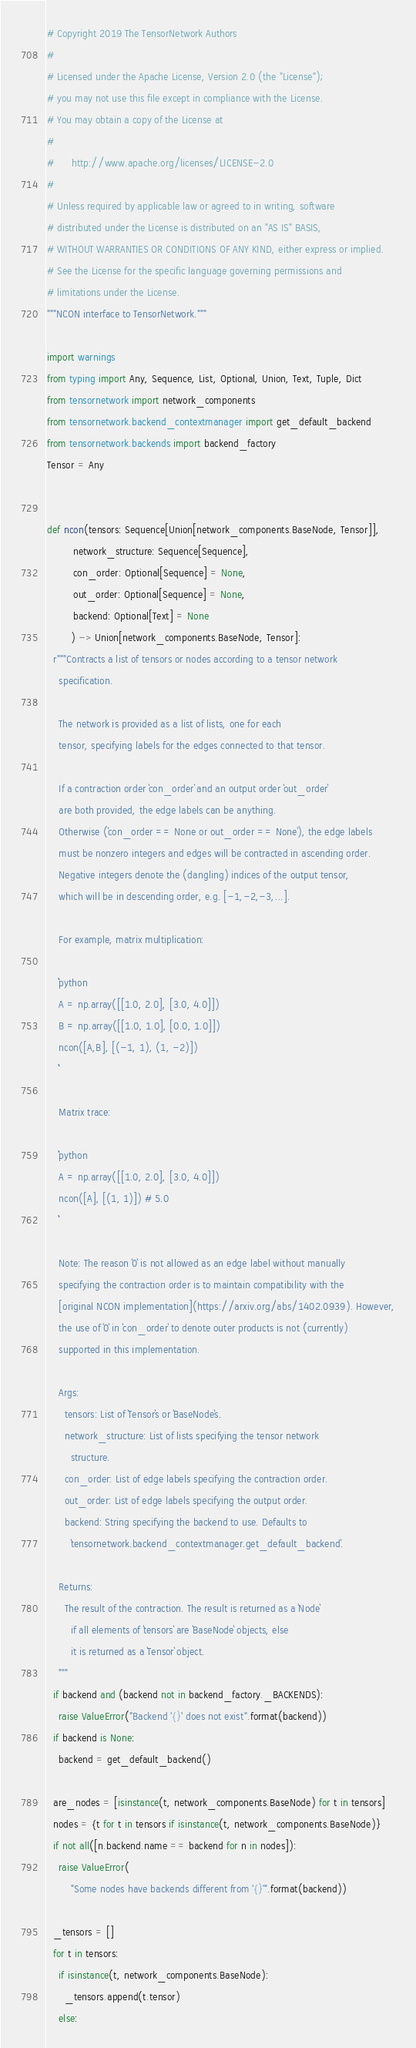Convert code to text. <code><loc_0><loc_0><loc_500><loc_500><_Python_># Copyright 2019 The TensorNetwork Authors
#
# Licensed under the Apache License, Version 2.0 (the "License");
# you may not use this file except in compliance with the License.
# You may obtain a copy of the License at
#
#      http://www.apache.org/licenses/LICENSE-2.0
#
# Unless required by applicable law or agreed to in writing, software
# distributed under the License is distributed on an "AS IS" BASIS,
# WITHOUT WARRANTIES OR CONDITIONS OF ANY KIND, either express or implied.
# See the License for the specific language governing permissions and
# limitations under the License.
"""NCON interface to TensorNetwork."""

import warnings
from typing import Any, Sequence, List, Optional, Union, Text, Tuple, Dict
from tensornetwork import network_components
from tensornetwork.backend_contextmanager import get_default_backend
from tensornetwork.backends import backend_factory
Tensor = Any


def ncon(tensors: Sequence[Union[network_components.BaseNode, Tensor]],
         network_structure: Sequence[Sequence],
         con_order: Optional[Sequence] = None,
         out_order: Optional[Sequence] = None,
         backend: Optional[Text] = None
        ) -> Union[network_components.BaseNode, Tensor]:
  r"""Contracts a list of tensors or nodes according to a tensor network 
    specification.

    The network is provided as a list of lists, one for each
    tensor, specifying labels for the edges connected to that tensor.

    If a contraction order `con_order` and an output order `out_order`
    are both provided, the edge labels can be anything.
    Otherwise (`con_order == None or out_order == None`), the edge labels 
    must be nonzero integers and edges will be contracted in ascending order.
    Negative integers denote the (dangling) indices of the output tensor,
    which will be in descending order, e.g. [-1,-2,-3,...].

    For example, matrix multiplication:

    ```python
    A = np.array([[1.0, 2.0], [3.0, 4.0]])
    B = np.array([[1.0, 1.0], [0.0, 1.0]])
    ncon([A,B], [(-1, 1), (1, -2)])
    ```

    Matrix trace:

    ```python
    A = np.array([[1.0, 2.0], [3.0, 4.0]])
    ncon([A], [(1, 1)]) # 5.0
    ```

    Note: The reason `0` is not allowed as an edge label without manually
    specifying the contraction order is to maintain compatibility with the
    [original NCON implementation](https://arxiv.org/abs/1402.0939). However,
    the use of `0` in `con_order` to denote outer products is not (currently) 
    supported in this implementation.

    Args:
      tensors: List of `Tensor`s or `BaseNode`s.
      network_structure: List of lists specifying the tensor network
        structure.
      con_order: List of edge labels specifying the contraction order.
      out_order: List of edge labels specifying the output order.
      backend: String specifying the backend to use. Defaults to
        `tensornetwork.backend_contextmanager.get_default_backend`.

    Returns:
      The result of the contraction. The result is returned as a `Node`
        if all elements of `tensors` are `BaseNode` objects, else
        it is returned as a `Tensor` object.
    """
  if backend and (backend not in backend_factory._BACKENDS):
    raise ValueError("Backend '{}' does not exist".format(backend))
  if backend is None:
    backend = get_default_backend()

  are_nodes = [isinstance(t, network_components.BaseNode) for t in tensors]
  nodes = {t for t in tensors if isinstance(t, network_components.BaseNode)}
  if not all([n.backend.name == backend for n in nodes]):
    raise ValueError(
        "Some nodes have backends different from '{}'".format(backend))

  _tensors = []
  for t in tensors:
    if isinstance(t, network_components.BaseNode):
      _tensors.append(t.tensor)
    else:</code> 